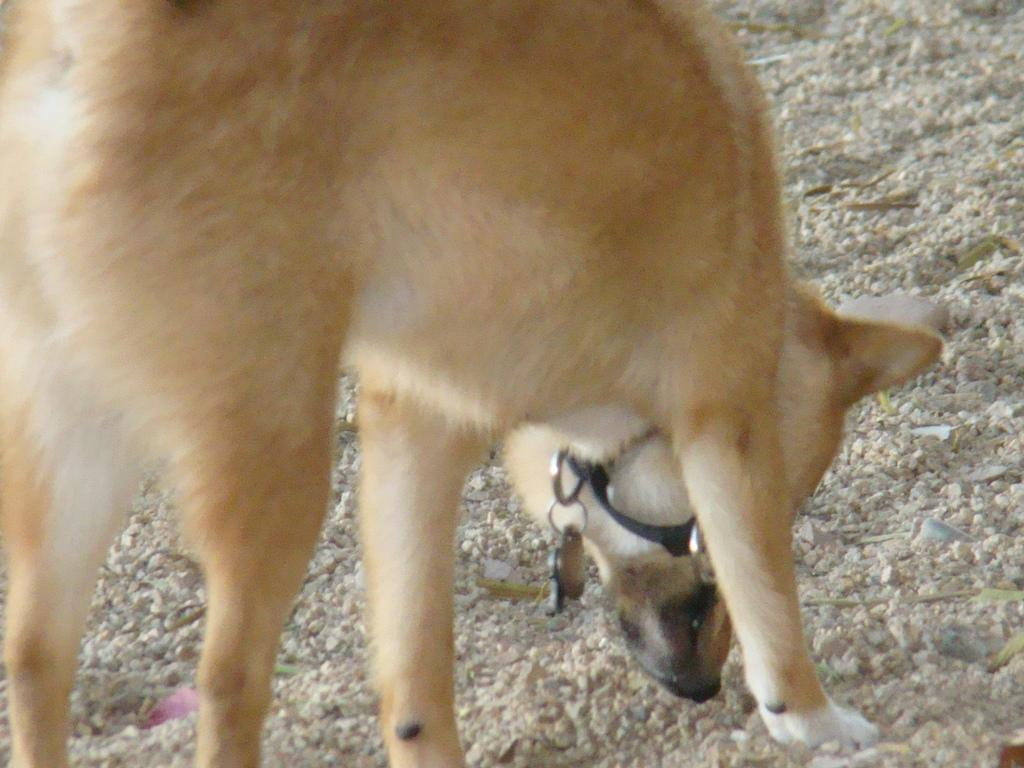What type of living creature is present in the image? There is an animal in the image. How much debt does the animal have in the image? There is no information about the animal's debt in the image, as it is not a relevant detail. 